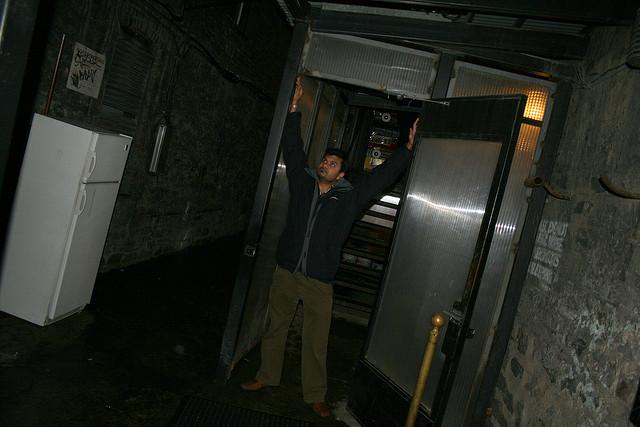How many arrows are in this picture?
Concise answer only. 0. Can you see through the glass on the door?
Short answer required. No. What is the black tubing on the wall used for?
Write a very short answer. Pipes. Which item casts a shadow on the wall?
Concise answer only. Person. Is the refrigerator open?
Short answer required. No. What is the man doing?
Short answer required. Standing. 